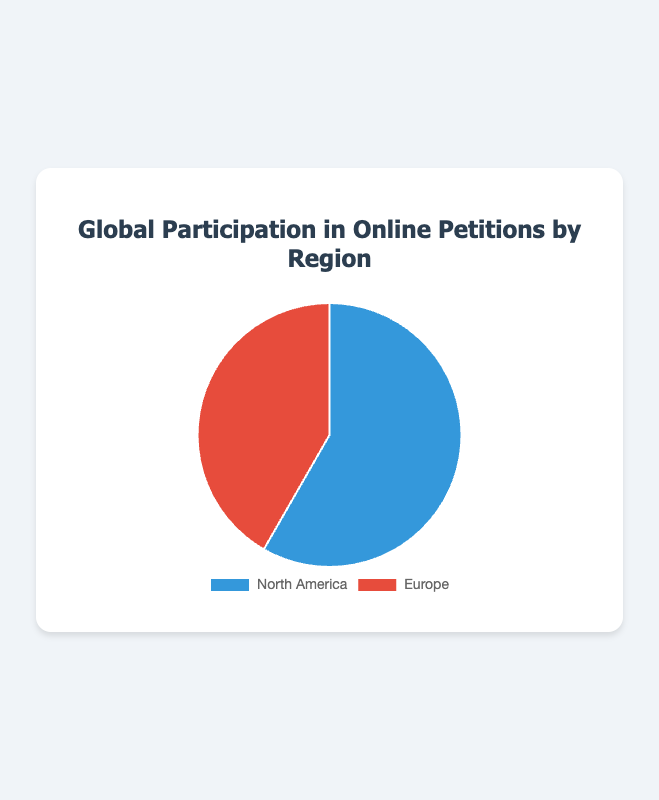What percentage of global participation in online petitions comes from North America? The figure shows that North America has a participation rate of 58.3%. You can see this data directly in the figure.
Answer: 58.3% How does the participation rate of Europe compare to North America in online petitions? From the figure, Europe has a participation rate of 41.7% while North America has 58.3%. Comparing them, North America has a higher rate of participation.
Answer: North America has a higher rate of participation What is the difference in participation rates between North America and Europe? By comparing the rates, North America's participation rate is 58.3% and Europe's is 41.7%. Subtract Europe's rate from North America's rate: 58.3% - 41.7% = 16.6%.
Answer: 16.6% What is the combined participation rate for both regions in online petitions? The sum of North America and Europe’s participation rates is 58.3% + 41.7%. Adding them together, you get 100%.
Answer: 100% From the figure, which region has a larger slice in the pie chart? Visually, North America's slice is larger due to its 58.3% participation rate compared to Europe's 41.7%.
Answer: North America If an online petition has 10,000 participants from both regions combined, approximately how many participants are from Europe and North America respectively? Total participants are 10,000. North America's share is 58.3% of 10,000 and Europe’s is 41.7%. Calculate 58.3% of 10,000: (58.3/100) * 10,000 = 5,830 for North America. Calculate 41.7% of 10,000: (41.7/100) * 10,000 = 4,170 for Europe.
Answer: 5,830 from North America, 4,170 from Europe 